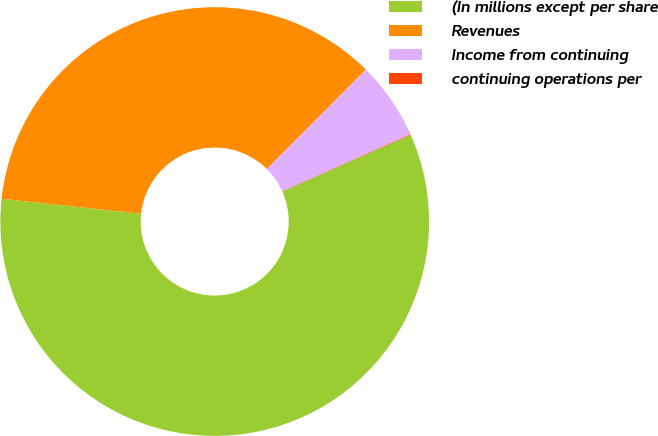Convert chart to OTSL. <chart><loc_0><loc_0><loc_500><loc_500><pie_chart><fcel>(In millions except per share<fcel>Revenues<fcel>Income from continuing<fcel>continuing operations per<nl><fcel>58.32%<fcel>35.77%<fcel>5.87%<fcel>0.04%<nl></chart> 